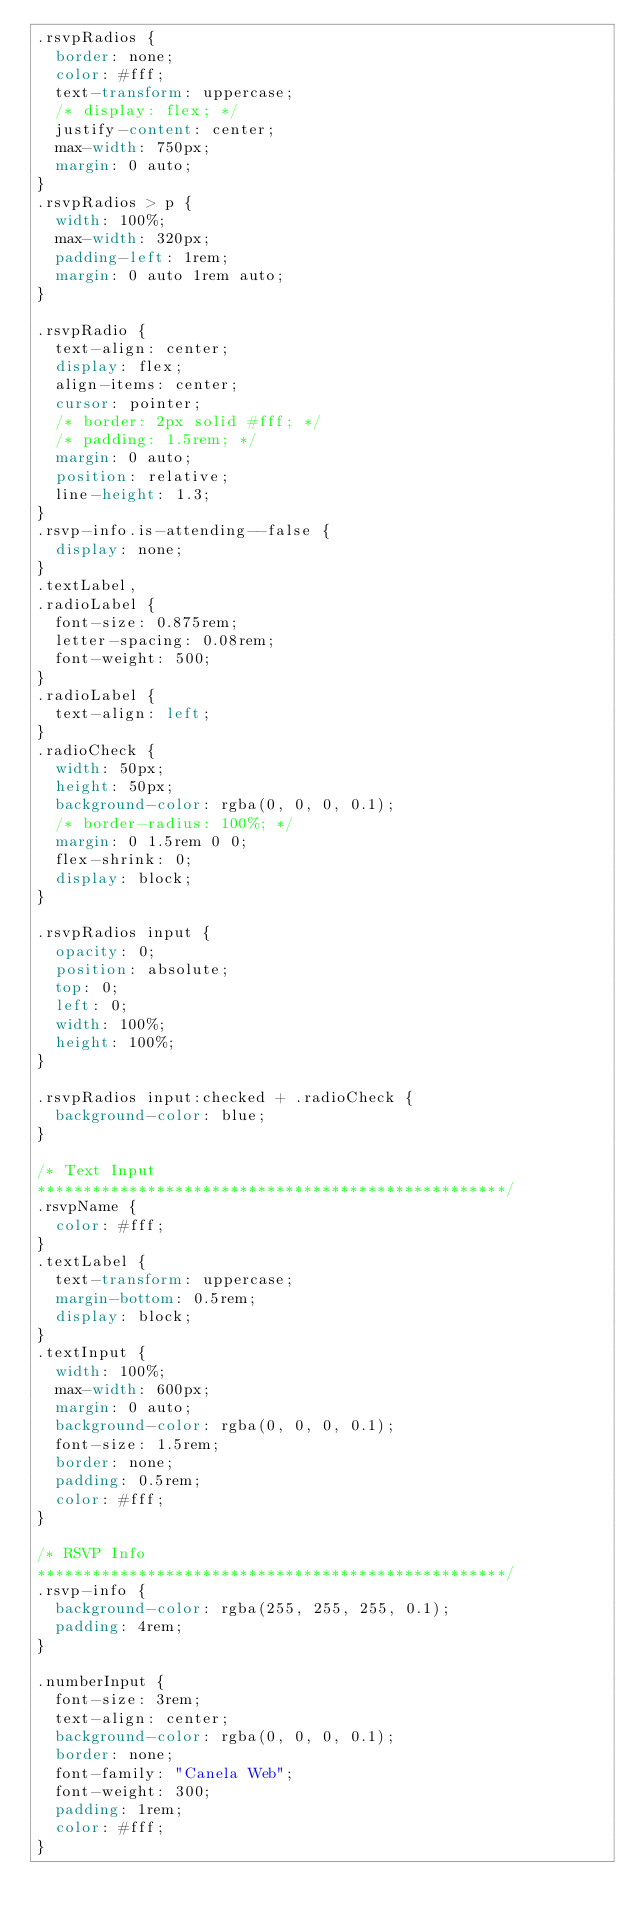<code> <loc_0><loc_0><loc_500><loc_500><_CSS_>.rsvpRadios {
  border: none;
  color: #fff;
  text-transform: uppercase;
  /* display: flex; */
  justify-content: center;
  max-width: 750px;
  margin: 0 auto;
}
.rsvpRadios > p {
  width: 100%;
  max-width: 320px;
  padding-left: 1rem;
  margin: 0 auto 1rem auto;
}

.rsvpRadio {
  text-align: center;
  display: flex;
  align-items: center;
  cursor: pointer;
  /* border: 2px solid #fff; */
  /* padding: 1.5rem; */
  margin: 0 auto;
  position: relative;
  line-height: 1.3;
}
.rsvp-info.is-attending--false {
  display: none;
}
.textLabel,
.radioLabel {
  font-size: 0.875rem;
  letter-spacing: 0.08rem;
  font-weight: 500;
}
.radioLabel {
  text-align: left;
}
.radioCheck {
  width: 50px;
  height: 50px;
  background-color: rgba(0, 0, 0, 0.1);
  /* border-radius: 100%; */
  margin: 0 1.5rem 0 0;
  flex-shrink: 0;
  display: block;
}

.rsvpRadios input {
  opacity: 0;
  position: absolute;
  top: 0;
  left: 0;
  width: 100%;
  height: 100%;
}

.rsvpRadios input:checked + .radioCheck {
  background-color: blue;
}

/* Text Input
***************************************************/
.rsvpName {
  color: #fff;
}
.textLabel {
  text-transform: uppercase;
  margin-bottom: 0.5rem;
  display: block;
}
.textInput {
  width: 100%;
  max-width: 600px;
  margin: 0 auto;
  background-color: rgba(0, 0, 0, 0.1);
  font-size: 1.5rem;
  border: none;
  padding: 0.5rem;
  color: #fff;
}

/* RSVP Info
***************************************************/
.rsvp-info {
  background-color: rgba(255, 255, 255, 0.1);
  padding: 4rem;
}

.numberInput {
  font-size: 3rem;
  text-align: center;
  background-color: rgba(0, 0, 0, 0.1);
  border: none;
  font-family: "Canela Web";
  font-weight: 300;
  padding: 1rem;
  color: #fff;
}
</code> 